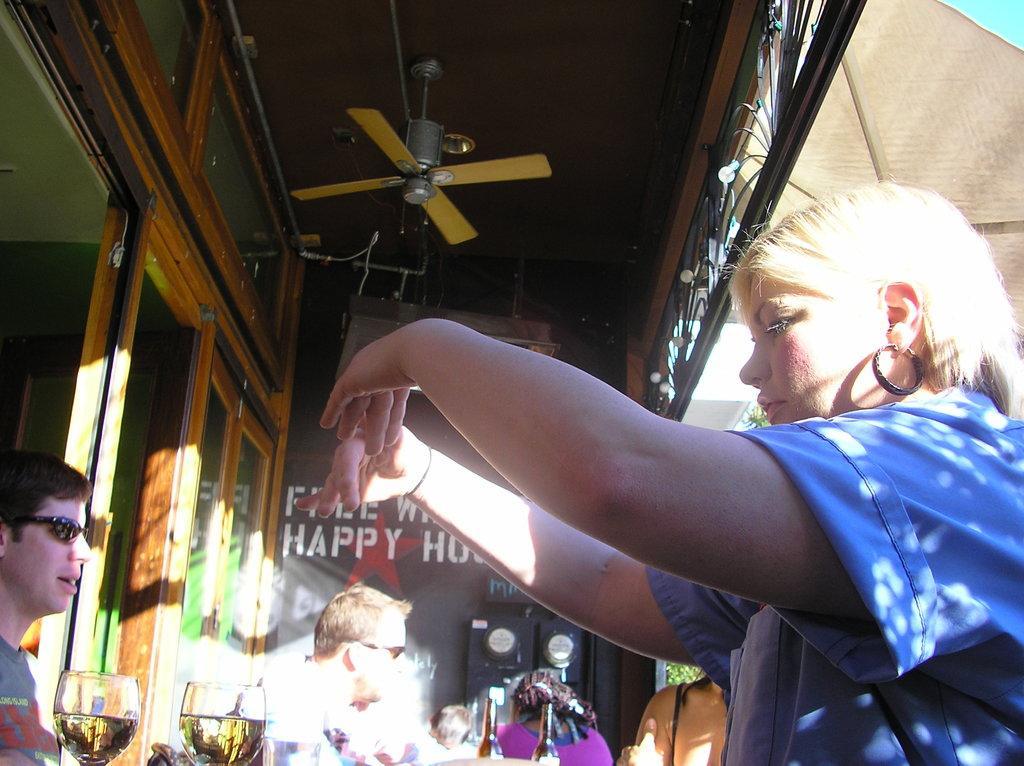Could you give a brief overview of what you see in this image? In this image in the foreground there is one woman, who is standing and on the left side there are some persons, glasses and some objects. In the background there is a board, and on the left side there are some windows and at the top there is ceiling and one fan. 